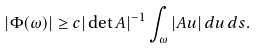Convert formula to latex. <formula><loc_0><loc_0><loc_500><loc_500>| \Phi ( \omega ) | \geq c | \det A | ^ { - 1 } \int _ { \omega } | A u | \, d u \, d s .</formula> 